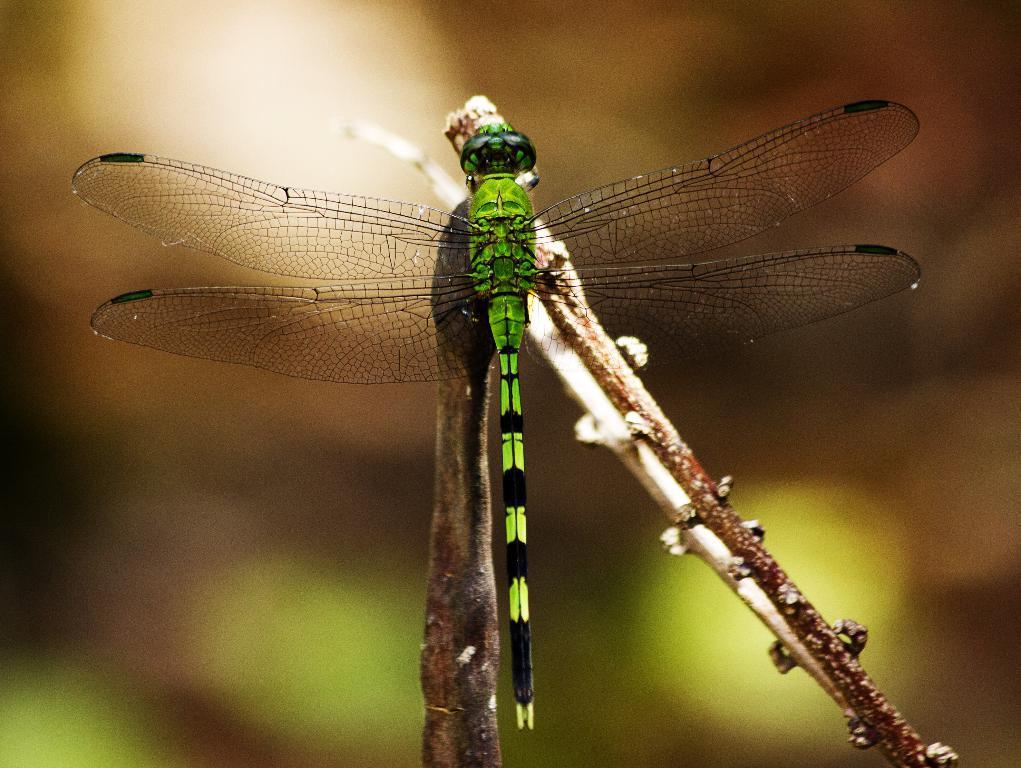In one or two sentences, can you explain what this image depicts? In the middle of the image we can see a dragonfly and we can find blurry background. 